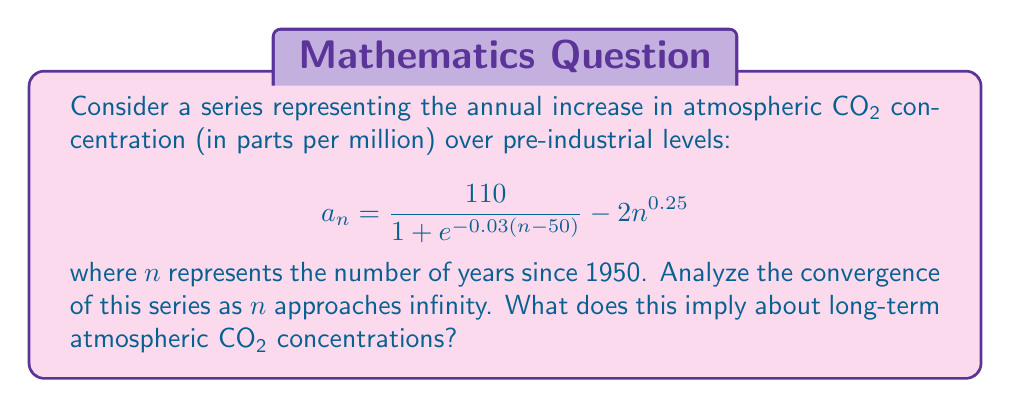Solve this math problem. To analyze the convergence of this series, we need to examine the behavior of the general term $a_n$ as $n$ approaches infinity.

1) First, let's consider the term $\frac{110}{1 + e^{-0.03(n-50)}}$:
   As $n \to \infty$, $e^{-0.03(n-50)} \to 0$, so this term approaches 110.

2) Now, let's look at $2n^{0.25}$:
   As $n \to \infty$, this term also approaches infinity, but at a slower rate than $n$.

3) Therefore, we can write:

   $$\lim_{n \to \infty} a_n = \lim_{n \to \infty} \left(\frac{110}{1 + e^{-0.03(n-50)}} - 2n^{0.25}\right) = 110 - \infty = -\infty$$

4) Since the limit of the general term is negative infinity, the series diverges by the divergence test.

5) To interpret this result in the context of atmospheric CO₂:
   - The first term represents a logistic growth model with a carrying capacity of 110 ppm above pre-industrial levels.
   - The second term represents efforts to reduce CO₂ concentrations, which become more effective over time.
   - The divergence to negative infinity suggests that, in this model, long-term reduction efforts outpace the natural increase, potentially leading to a net decrease in atmospheric CO₂ concentrations.

However, it's important to note that this is a simplified mathematical model and real-world climate dynamics are much more complex.
Answer: The series diverges to negative infinity. This implies that, according to this mathematical model, long-term efforts to reduce atmospheric CO₂ concentrations could potentially outpace the natural increase, leading to a net decrease in CO₂ levels over time. 